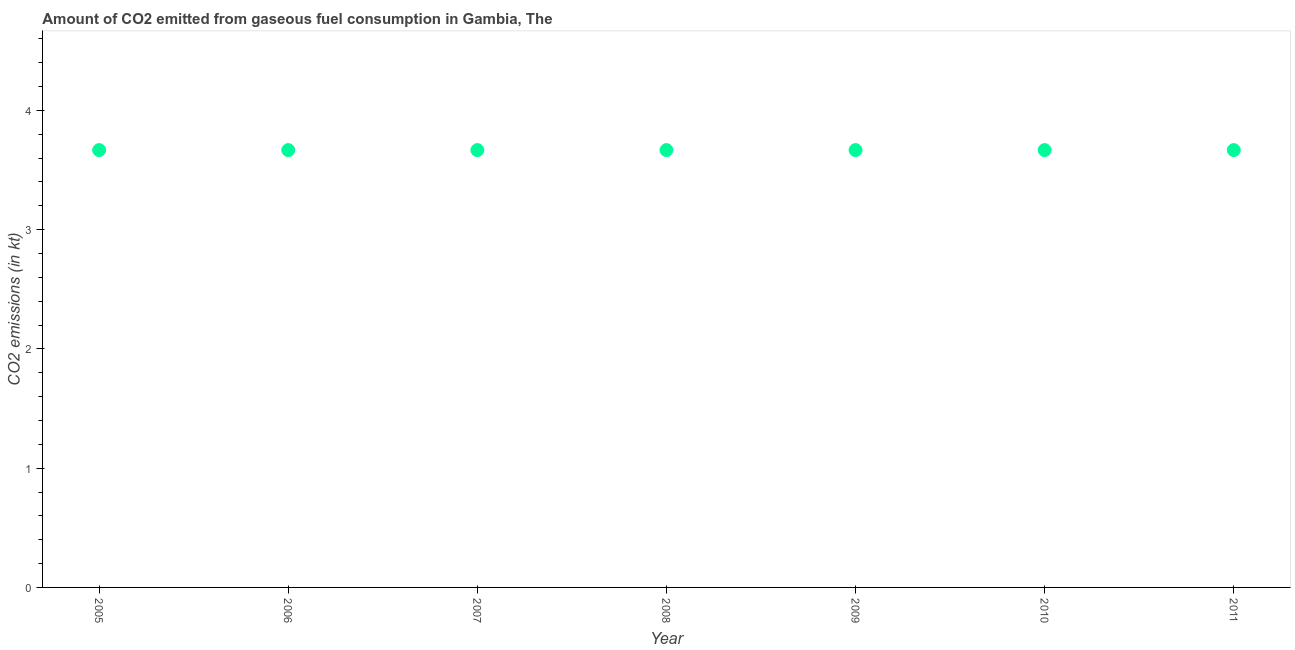What is the co2 emissions from gaseous fuel consumption in 2011?
Your answer should be very brief. 3.67. Across all years, what is the maximum co2 emissions from gaseous fuel consumption?
Your response must be concise. 3.67. Across all years, what is the minimum co2 emissions from gaseous fuel consumption?
Ensure brevity in your answer.  3.67. What is the sum of the co2 emissions from gaseous fuel consumption?
Give a very brief answer. 25.67. What is the average co2 emissions from gaseous fuel consumption per year?
Provide a succinct answer. 3.67. What is the median co2 emissions from gaseous fuel consumption?
Your response must be concise. 3.67. In how many years, is the co2 emissions from gaseous fuel consumption greater than 3.2 kt?
Ensure brevity in your answer.  7. Is the co2 emissions from gaseous fuel consumption in 2005 less than that in 2008?
Keep it short and to the point. No. Is the difference between the co2 emissions from gaseous fuel consumption in 2006 and 2008 greater than the difference between any two years?
Give a very brief answer. Yes. What is the difference between the highest and the lowest co2 emissions from gaseous fuel consumption?
Provide a short and direct response. 0. In how many years, is the co2 emissions from gaseous fuel consumption greater than the average co2 emissions from gaseous fuel consumption taken over all years?
Offer a very short reply. 0. Does the co2 emissions from gaseous fuel consumption monotonically increase over the years?
Offer a very short reply. No. How many dotlines are there?
Your response must be concise. 1. How many years are there in the graph?
Give a very brief answer. 7. What is the difference between two consecutive major ticks on the Y-axis?
Provide a succinct answer. 1. Does the graph contain any zero values?
Provide a succinct answer. No. Does the graph contain grids?
Your response must be concise. No. What is the title of the graph?
Your answer should be very brief. Amount of CO2 emitted from gaseous fuel consumption in Gambia, The. What is the label or title of the X-axis?
Offer a terse response. Year. What is the label or title of the Y-axis?
Your response must be concise. CO2 emissions (in kt). What is the CO2 emissions (in kt) in 2005?
Your answer should be compact. 3.67. What is the CO2 emissions (in kt) in 2006?
Ensure brevity in your answer.  3.67. What is the CO2 emissions (in kt) in 2007?
Offer a terse response. 3.67. What is the CO2 emissions (in kt) in 2008?
Offer a very short reply. 3.67. What is the CO2 emissions (in kt) in 2009?
Your response must be concise. 3.67. What is the CO2 emissions (in kt) in 2010?
Provide a succinct answer. 3.67. What is the CO2 emissions (in kt) in 2011?
Offer a terse response. 3.67. What is the difference between the CO2 emissions (in kt) in 2005 and 2006?
Make the answer very short. 0. What is the difference between the CO2 emissions (in kt) in 2005 and 2008?
Provide a succinct answer. 0. What is the difference between the CO2 emissions (in kt) in 2006 and 2007?
Ensure brevity in your answer.  0. What is the difference between the CO2 emissions (in kt) in 2006 and 2009?
Provide a succinct answer. 0. What is the difference between the CO2 emissions (in kt) in 2006 and 2011?
Give a very brief answer. 0. What is the difference between the CO2 emissions (in kt) in 2007 and 2008?
Ensure brevity in your answer.  0. What is the difference between the CO2 emissions (in kt) in 2007 and 2009?
Make the answer very short. 0. What is the difference between the CO2 emissions (in kt) in 2007 and 2011?
Keep it short and to the point. 0. What is the difference between the CO2 emissions (in kt) in 2009 and 2010?
Offer a very short reply. 0. What is the ratio of the CO2 emissions (in kt) in 2005 to that in 2006?
Offer a terse response. 1. What is the ratio of the CO2 emissions (in kt) in 2005 to that in 2010?
Provide a short and direct response. 1. What is the ratio of the CO2 emissions (in kt) in 2006 to that in 2007?
Provide a succinct answer. 1. What is the ratio of the CO2 emissions (in kt) in 2006 to that in 2008?
Ensure brevity in your answer.  1. What is the ratio of the CO2 emissions (in kt) in 2006 to that in 2009?
Offer a terse response. 1. What is the ratio of the CO2 emissions (in kt) in 2006 to that in 2011?
Your answer should be compact. 1. What is the ratio of the CO2 emissions (in kt) in 2007 to that in 2011?
Provide a succinct answer. 1. What is the ratio of the CO2 emissions (in kt) in 2008 to that in 2011?
Your answer should be very brief. 1. What is the ratio of the CO2 emissions (in kt) in 2009 to that in 2011?
Keep it short and to the point. 1. What is the ratio of the CO2 emissions (in kt) in 2010 to that in 2011?
Your answer should be very brief. 1. 